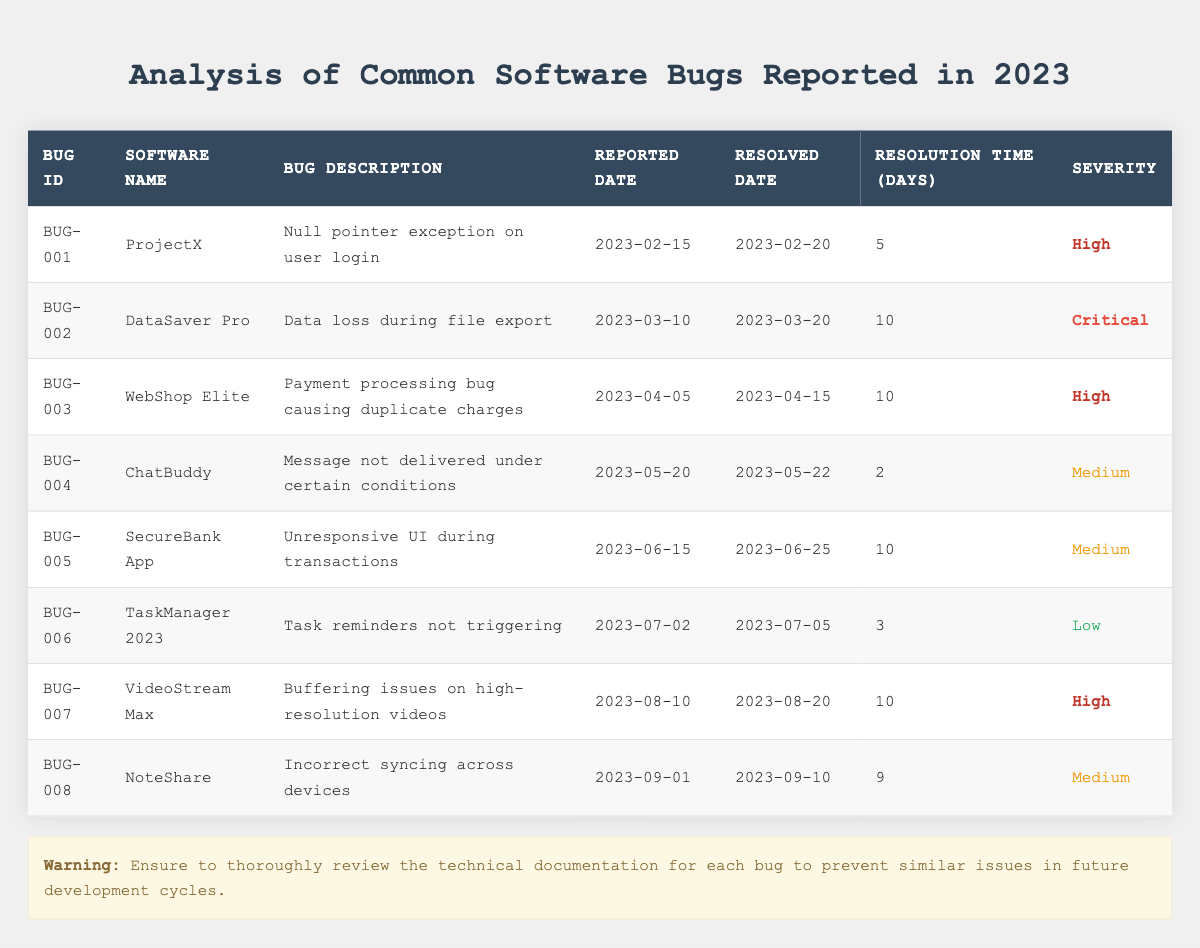What is the severity of the bug identified as BUG-002? The table shows that the severity listed for BUG-002, which is related to "DataSaver Pro" and describes data loss during file export, is labeled as "Critical."
Answer: Critical How many days did it take to resolve the bug in "ChatBuddy"? According to the table, the resolution time for the bug in "ChatBuddy" (BUG-004) is recorded as 2 days.
Answer: 2 Which software had the highest resolution time for its reported bug? By examining the table, the software "DataSaver Pro" (BUG-002) and "SecureBank App" (BUG-005) both took 10 days to resolve their bugs, which is the longest resolution time in the table.
Answer: DataSaver Pro and SecureBank App What percentage of reported bugs had a severity level of "High"? There are 8 total bugs, and 4 of them have a severity level of "High" (BUG-001, BUG-003, BUG-007). The percentage is calculated as (4/8) * 100 = 50%.
Answer: 50% Did "TaskManager 2023" have a bug that was resolved within 5 days? Looking at the table, the bug for "TaskManager 2023" (BUG-006) has a resolution time of 3 days, which is indeed less than 5 days. Therefore, the answer is yes.
Answer: Yes What is the average resolution time for bugs labeled "Medium"? The average resolution time for medium severity bugs calculated from "ChatBuddy" (2 days), "SecureBank App" (10 days), and "NoteShare" (9 days) is (2 + 10 + 9) / 3 = 21 / 3 = 7 days.
Answer: 7 Which bug was resolved the quickest? The table indicates that the quickest resolution time is for the bug in "ChatBuddy" (BUG-004), which was resolved in 2 days.
Answer: BUG-004 (ChatBuddy) Is there any bug reported in April that is labeled as "Critical"? The table does not show any bugs labeled as "Critical" for those reported in April; the only critical bug is "DataSaver Pro," reported in March. Therefore, the answer is no.
Answer: No 